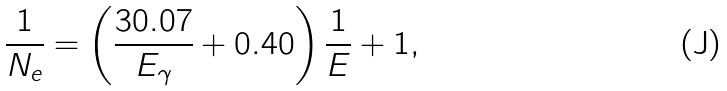<formula> <loc_0><loc_0><loc_500><loc_500>\frac { 1 } { N _ { e } } = \left ( \frac { 3 0 . 0 7 } { E _ { \gamma } } + 0 . 4 0 \right ) \frac { 1 } { E } + 1 ,</formula> 